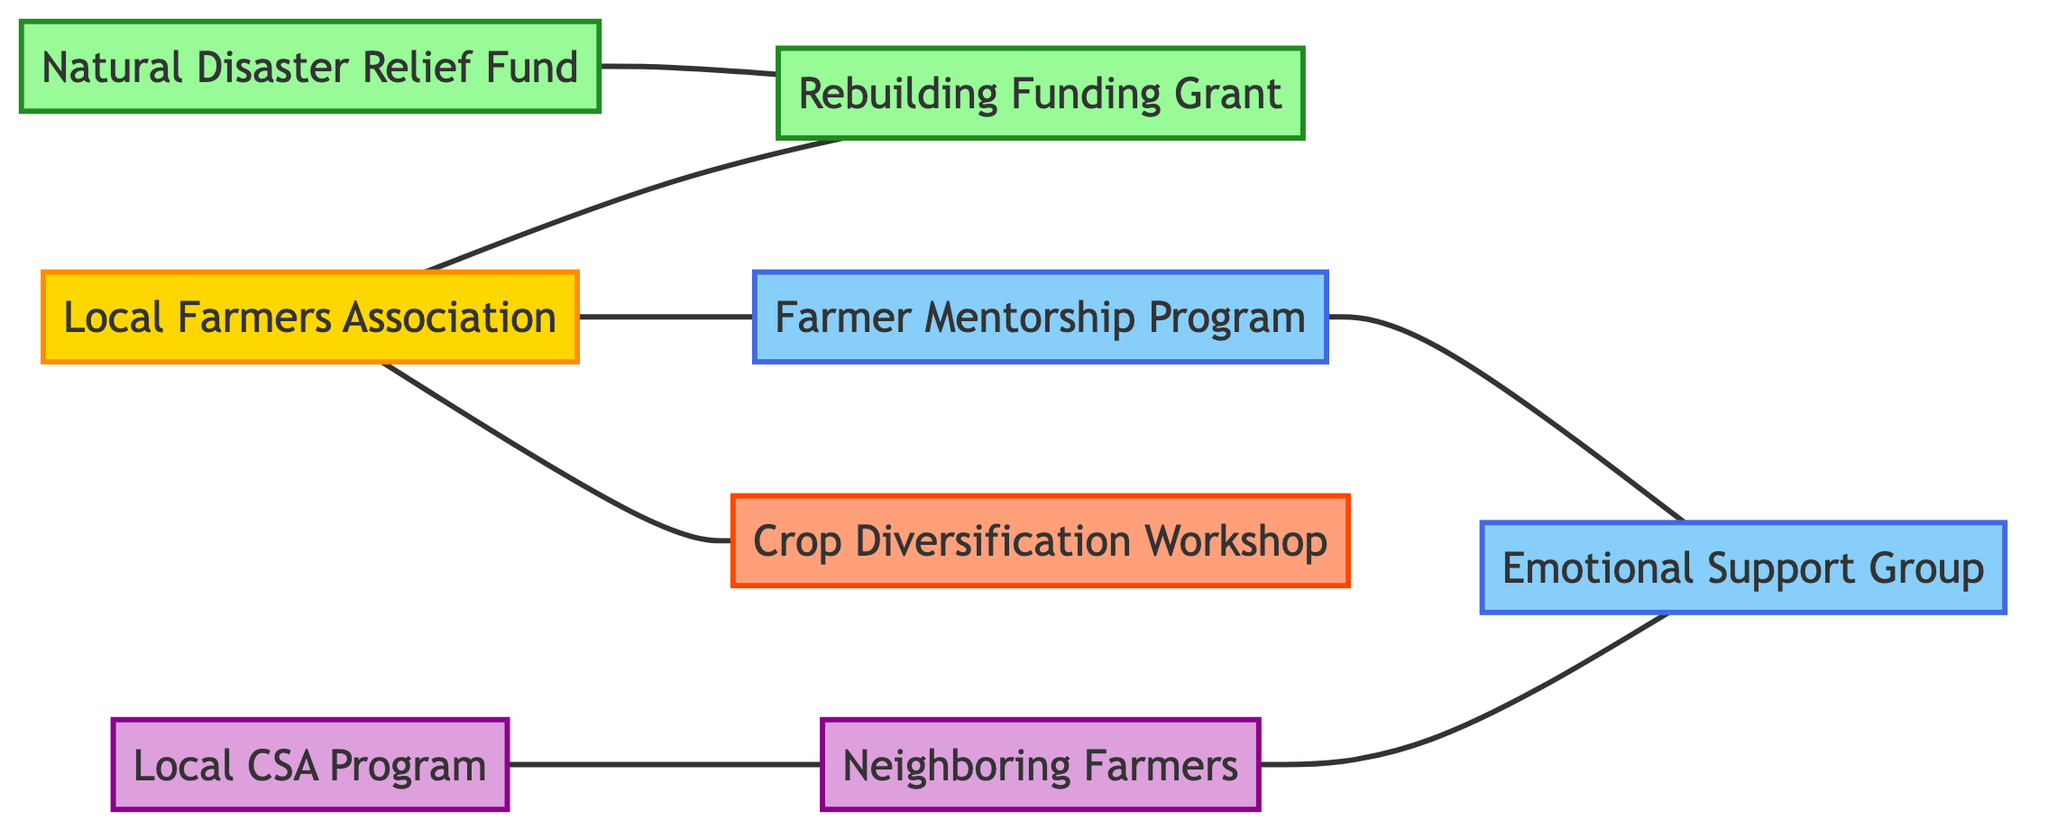What organization hosts the Crop Diversification Workshop? The diagram shows that the Local Farmers Association has a direct relationship indicating it hosts the Crop Diversification Workshop.
Answer: Local Farmers Association How many nodes are there in the diagram? By counting the listed nodes in the provided data, there are a total of 8 unique nodes representing different entities.
Answer: 8 Which support group includes the Farmer Mentorship Program? The emotional support group participates in and is included as part of the Farmer Mentorship Program, indicating a direct relationship.
Answer: Emotional Support Group What resource supplements the Rebuilding Funding Grant? The Natural Disaster Relief Fund has a direct relationship with the Rebuilding Funding Grant indicating it supplements this resource.
Answer: Natural Disaster Relief Fund Who collaborates with Neighboring Farmers? The Local CSA Program collaborates with Neighboring Farmers as indicated by the direct relationship defined in the edges of the diagram.
Answer: Local CSA Program What type of initiative is the Farmer Mentorship Program? The diagram categorizes the Farmer Mentorship Program under support initiatives, based on its classification as one of the nodes.
Answer: Support What is provided by the Local Farmers Association? The Local Farmers Association provides a Rebuilding Funding Grant, as indicated by the relationship noted in the diagram.
Answer: Rebuilding Funding Grant How many resources are present in the diagram? By examining the nodes, two resources can be identified: the Rebuilding Funding Grant and the Natural Disaster Relief Fund.
Answer: 2 